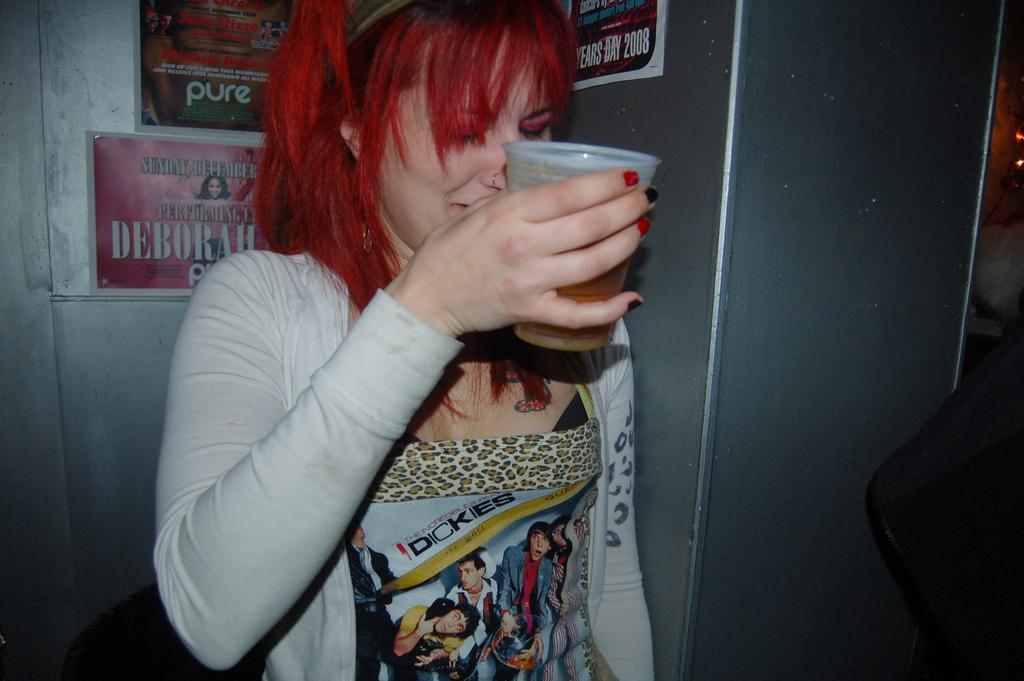Who is present in the image? There is a woman in the image. What is the woman holding in the image? The woman is holding a glass. What can be seen on the wall in the image? There are posters on an iron wall in the image. What is located on the right side of the image? There is a black object on the right side of the image. What type of competition is the woman participating in, as seen in the image? There is no competition present in the image; it simply shows a woman holding a glass and posters on an iron wall. How many pets can be seen in the image? There are no pets visible in the image. 